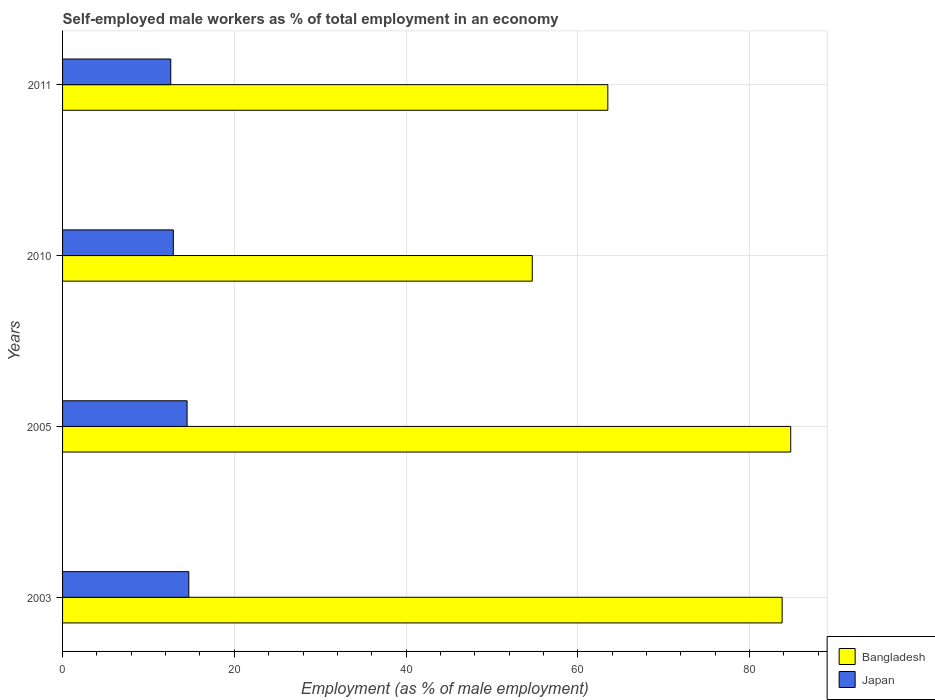Are the number of bars per tick equal to the number of legend labels?
Provide a succinct answer. Yes. Are the number of bars on each tick of the Y-axis equal?
Offer a very short reply. Yes. How many bars are there on the 1st tick from the top?
Offer a terse response. 2. What is the label of the 1st group of bars from the top?
Your answer should be compact. 2011. In how many cases, is the number of bars for a given year not equal to the number of legend labels?
Ensure brevity in your answer.  0. What is the percentage of self-employed male workers in Japan in 2010?
Provide a short and direct response. 12.9. Across all years, what is the maximum percentage of self-employed male workers in Bangladesh?
Your response must be concise. 84.8. Across all years, what is the minimum percentage of self-employed male workers in Japan?
Your response must be concise. 12.6. What is the total percentage of self-employed male workers in Japan in the graph?
Provide a succinct answer. 54.7. What is the difference between the percentage of self-employed male workers in Bangladesh in 2005 and that in 2010?
Your response must be concise. 30.1. What is the difference between the percentage of self-employed male workers in Japan in 2005 and the percentage of self-employed male workers in Bangladesh in 2011?
Provide a short and direct response. -49. What is the average percentage of self-employed male workers in Bangladesh per year?
Offer a terse response. 71.7. In the year 2010, what is the difference between the percentage of self-employed male workers in Bangladesh and percentage of self-employed male workers in Japan?
Offer a terse response. 41.8. In how many years, is the percentage of self-employed male workers in Japan greater than 56 %?
Provide a succinct answer. 0. What is the ratio of the percentage of self-employed male workers in Bangladesh in 2005 to that in 2011?
Offer a very short reply. 1.34. Is the difference between the percentage of self-employed male workers in Bangladesh in 2010 and 2011 greater than the difference between the percentage of self-employed male workers in Japan in 2010 and 2011?
Ensure brevity in your answer.  No. What is the difference between the highest and the lowest percentage of self-employed male workers in Japan?
Your answer should be very brief. 2.1. In how many years, is the percentage of self-employed male workers in Japan greater than the average percentage of self-employed male workers in Japan taken over all years?
Make the answer very short. 2. What does the 1st bar from the bottom in 2011 represents?
Ensure brevity in your answer.  Bangladesh. How many years are there in the graph?
Keep it short and to the point. 4. What is the difference between two consecutive major ticks on the X-axis?
Your answer should be very brief. 20. Are the values on the major ticks of X-axis written in scientific E-notation?
Offer a very short reply. No. Does the graph contain grids?
Provide a short and direct response. Yes. Where does the legend appear in the graph?
Keep it short and to the point. Bottom right. What is the title of the graph?
Offer a very short reply. Self-employed male workers as % of total employment in an economy. What is the label or title of the X-axis?
Keep it short and to the point. Employment (as % of male employment). What is the label or title of the Y-axis?
Give a very brief answer. Years. What is the Employment (as % of male employment) of Bangladesh in 2003?
Provide a succinct answer. 83.8. What is the Employment (as % of male employment) in Japan in 2003?
Provide a short and direct response. 14.7. What is the Employment (as % of male employment) in Bangladesh in 2005?
Keep it short and to the point. 84.8. What is the Employment (as % of male employment) in Japan in 2005?
Give a very brief answer. 14.5. What is the Employment (as % of male employment) in Bangladesh in 2010?
Your answer should be compact. 54.7. What is the Employment (as % of male employment) of Japan in 2010?
Your answer should be compact. 12.9. What is the Employment (as % of male employment) in Bangladesh in 2011?
Your answer should be compact. 63.5. What is the Employment (as % of male employment) of Japan in 2011?
Offer a terse response. 12.6. Across all years, what is the maximum Employment (as % of male employment) in Bangladesh?
Provide a short and direct response. 84.8. Across all years, what is the maximum Employment (as % of male employment) in Japan?
Keep it short and to the point. 14.7. Across all years, what is the minimum Employment (as % of male employment) in Bangladesh?
Provide a succinct answer. 54.7. Across all years, what is the minimum Employment (as % of male employment) of Japan?
Your answer should be very brief. 12.6. What is the total Employment (as % of male employment) of Bangladesh in the graph?
Provide a short and direct response. 286.8. What is the total Employment (as % of male employment) of Japan in the graph?
Provide a short and direct response. 54.7. What is the difference between the Employment (as % of male employment) in Bangladesh in 2003 and that in 2010?
Provide a succinct answer. 29.1. What is the difference between the Employment (as % of male employment) in Bangladesh in 2003 and that in 2011?
Ensure brevity in your answer.  20.3. What is the difference between the Employment (as % of male employment) in Bangladesh in 2005 and that in 2010?
Provide a short and direct response. 30.1. What is the difference between the Employment (as % of male employment) of Japan in 2005 and that in 2010?
Give a very brief answer. 1.6. What is the difference between the Employment (as % of male employment) of Bangladesh in 2005 and that in 2011?
Ensure brevity in your answer.  21.3. What is the difference between the Employment (as % of male employment) of Bangladesh in 2003 and the Employment (as % of male employment) of Japan in 2005?
Your answer should be compact. 69.3. What is the difference between the Employment (as % of male employment) of Bangladesh in 2003 and the Employment (as % of male employment) of Japan in 2010?
Give a very brief answer. 70.9. What is the difference between the Employment (as % of male employment) of Bangladesh in 2003 and the Employment (as % of male employment) of Japan in 2011?
Offer a terse response. 71.2. What is the difference between the Employment (as % of male employment) in Bangladesh in 2005 and the Employment (as % of male employment) in Japan in 2010?
Make the answer very short. 71.9. What is the difference between the Employment (as % of male employment) of Bangladesh in 2005 and the Employment (as % of male employment) of Japan in 2011?
Provide a succinct answer. 72.2. What is the difference between the Employment (as % of male employment) of Bangladesh in 2010 and the Employment (as % of male employment) of Japan in 2011?
Offer a terse response. 42.1. What is the average Employment (as % of male employment) in Bangladesh per year?
Make the answer very short. 71.7. What is the average Employment (as % of male employment) of Japan per year?
Your answer should be compact. 13.68. In the year 2003, what is the difference between the Employment (as % of male employment) in Bangladesh and Employment (as % of male employment) in Japan?
Your response must be concise. 69.1. In the year 2005, what is the difference between the Employment (as % of male employment) in Bangladesh and Employment (as % of male employment) in Japan?
Ensure brevity in your answer.  70.3. In the year 2010, what is the difference between the Employment (as % of male employment) of Bangladesh and Employment (as % of male employment) of Japan?
Ensure brevity in your answer.  41.8. In the year 2011, what is the difference between the Employment (as % of male employment) of Bangladesh and Employment (as % of male employment) of Japan?
Your answer should be very brief. 50.9. What is the ratio of the Employment (as % of male employment) in Japan in 2003 to that in 2005?
Offer a very short reply. 1.01. What is the ratio of the Employment (as % of male employment) of Bangladesh in 2003 to that in 2010?
Provide a succinct answer. 1.53. What is the ratio of the Employment (as % of male employment) of Japan in 2003 to that in 2010?
Your answer should be compact. 1.14. What is the ratio of the Employment (as % of male employment) of Bangladesh in 2003 to that in 2011?
Make the answer very short. 1.32. What is the ratio of the Employment (as % of male employment) in Bangladesh in 2005 to that in 2010?
Keep it short and to the point. 1.55. What is the ratio of the Employment (as % of male employment) in Japan in 2005 to that in 2010?
Offer a very short reply. 1.12. What is the ratio of the Employment (as % of male employment) of Bangladesh in 2005 to that in 2011?
Provide a succinct answer. 1.34. What is the ratio of the Employment (as % of male employment) in Japan in 2005 to that in 2011?
Your answer should be very brief. 1.15. What is the ratio of the Employment (as % of male employment) of Bangladesh in 2010 to that in 2011?
Offer a very short reply. 0.86. What is the ratio of the Employment (as % of male employment) of Japan in 2010 to that in 2011?
Keep it short and to the point. 1.02. What is the difference between the highest and the second highest Employment (as % of male employment) of Bangladesh?
Offer a very short reply. 1. What is the difference between the highest and the second highest Employment (as % of male employment) of Japan?
Offer a terse response. 0.2. What is the difference between the highest and the lowest Employment (as % of male employment) in Bangladesh?
Offer a very short reply. 30.1. What is the difference between the highest and the lowest Employment (as % of male employment) of Japan?
Keep it short and to the point. 2.1. 